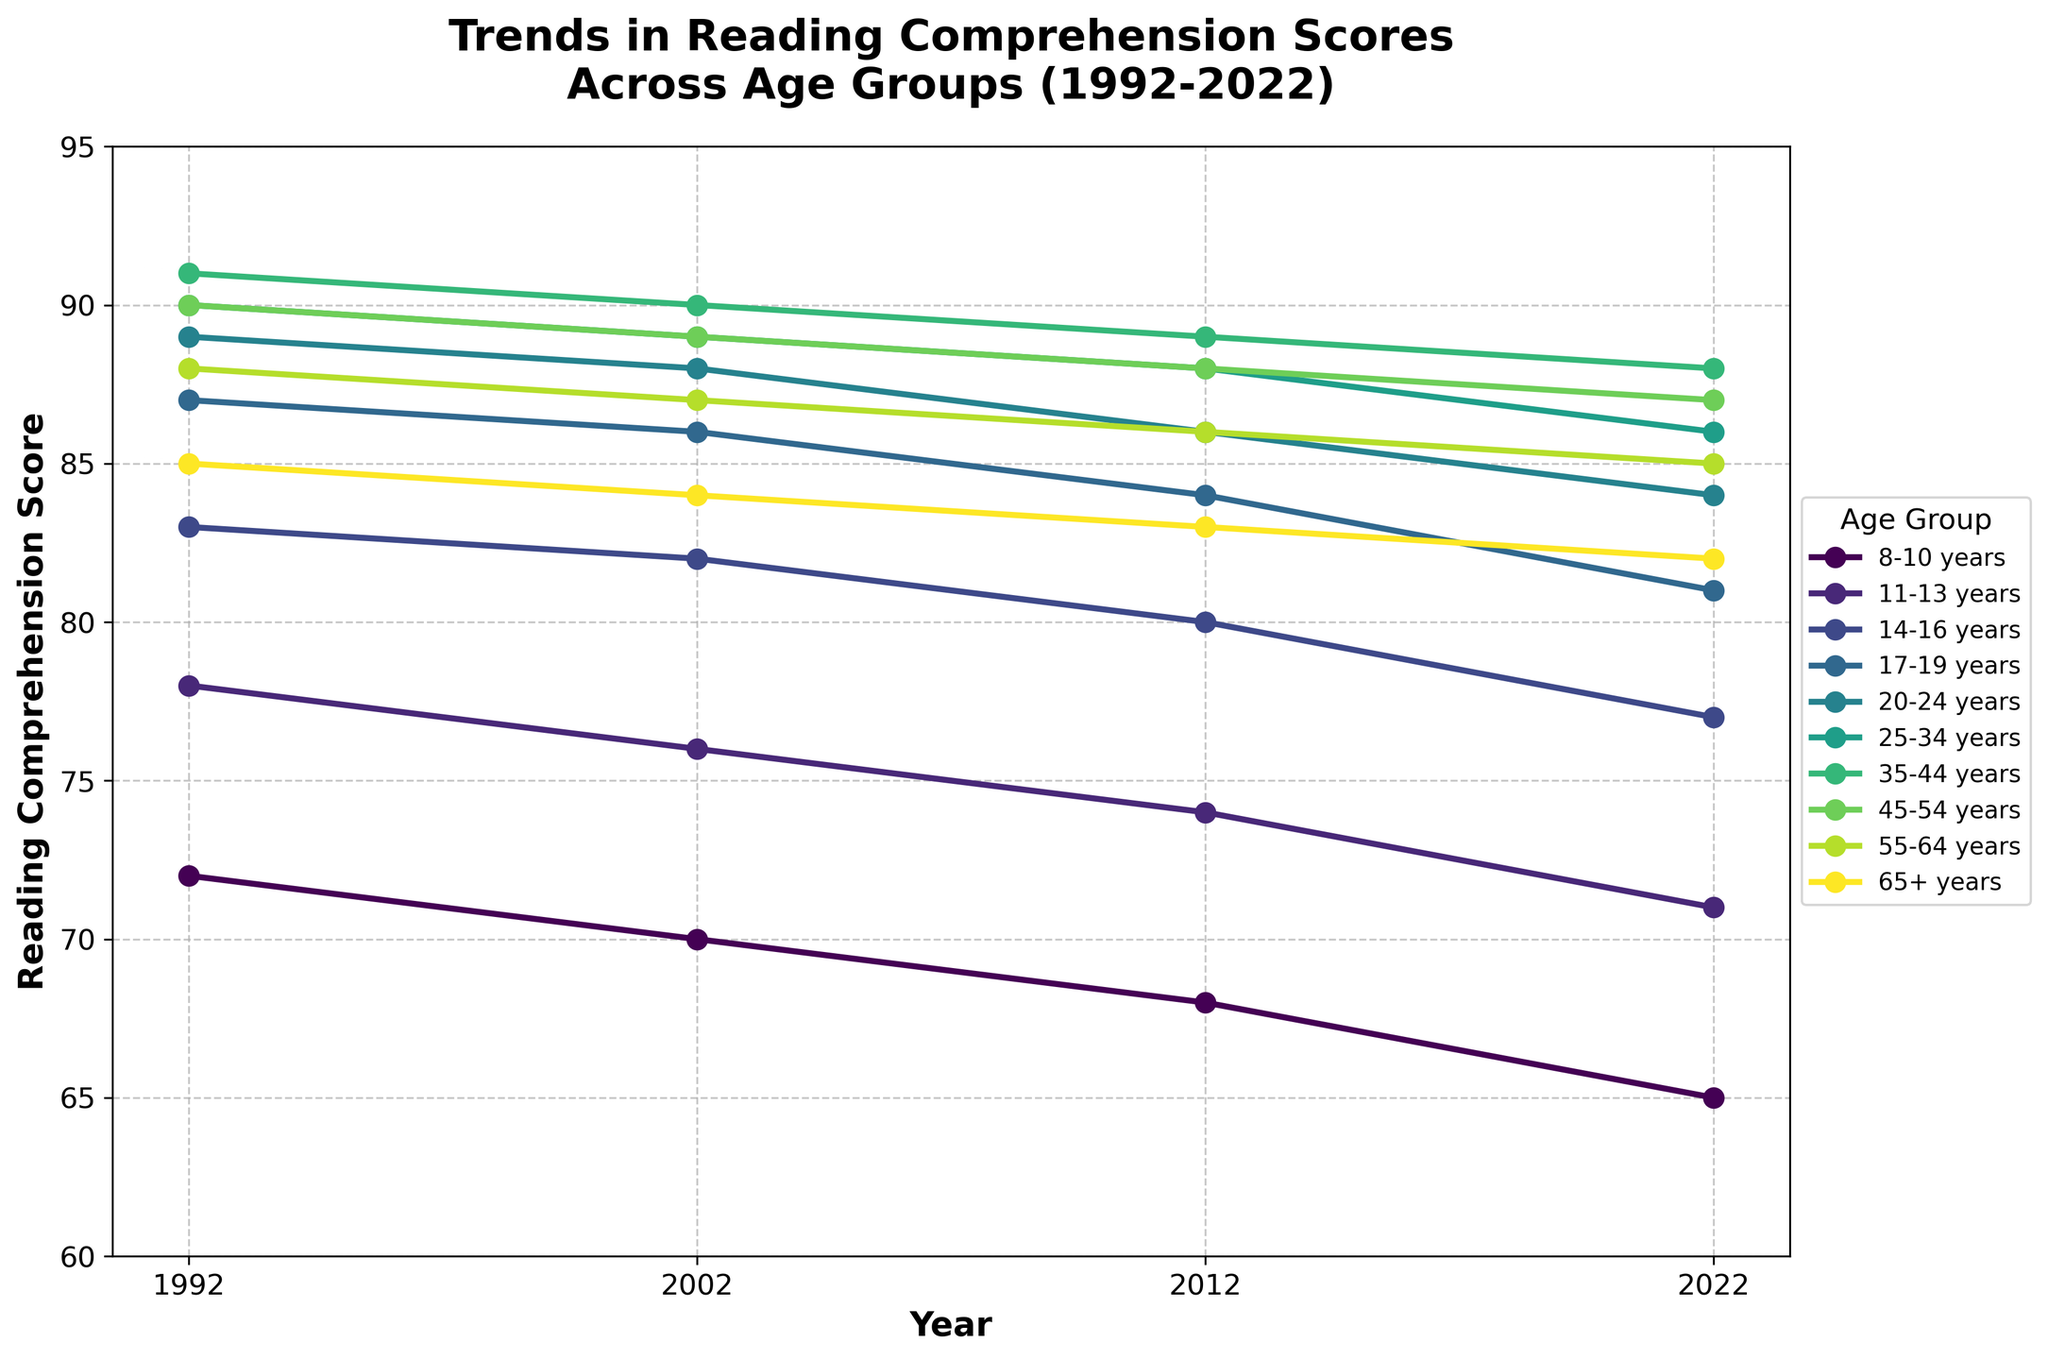Which age group exhibited the highest reading comprehension score in 2022? Look at the 2022 values on the plot and identify the highest value. The age group with the highest score is 35-44 years, with a score of 88.
Answer: 35-44 years How did the score for the 17-19 years age group change from 1992 to 2022? Examine the line for the 17-19 years group. In 1992, the score was 87. By 2022, it dropped to 81. The change is a decrease of 6 points.
Answer: Decreased by 6 points Between which years did the 8-10 years age group see the steepest decline in reading comprehension scores? Compare the slopes of the 8-10 years age group's line segments between each set of consecutive years. The steepest decline is from 2012 to 2022, where the score dropped from 68 to 65, a decline of 3 points.
Answer: 2012 to 2022 What is the average score for the 25-34 years age group over the 30 years? Sum the scores for the 25-34 years age group: 90 + 89 + 88 + 86. Divide this sum by the number of data points, 4. Hence, (90 + 89 + 88 + 86) / 4 = 88.25.
Answer: 88.25 How many age groups had scores above 85 in 1992? Observe the 1992 values and count the age groups with scores above 85. The groups are 14-16, 17-19, 20-24, 25-34, and 35-44 years, making a total of 5 age groups.
Answer: 5 Which age group had the smallest total drop in scores over the 30 years? Calculate the total drop for each age group by subtracting the 2022 score from the 1992 score. The group with the smallest drop is 35-44 years, with a drop from 91 to 88, resulting in a decrease of 3 points.
Answer: 35-44 years Which age group's scores are represented by the color at the top of the color palette? Look at the line color corresponding to the age group at the topmost position in the color gradient on the plot. This age group is 8-10 years.
Answer: 8-10 years Compare the scores of the 55-64 years and 65+ years age groups in 2022. Which one is higher? Compare the 2022 scores for both groups. The 55-64 years group has a score of 85, while the 65+ years group has a score of 82. The 55-64 years group's score is higher.
Answer: 55-64 years What is the average change in reading comprehension scores for the 14-16 years age group from each decade to the next? Calculate the differences for the 14-16 years age group's scores for each interval: 83 to 82 (1992-2002), 82 to 80 (2002-2012), and 80 to 77 (2012-2022). The total change is (83-82) + (82-80) + (80-77) = 3. Divide this by the number of intervals, 3: 3 / 3 = 1.
Answer: 1 Which age group experienced the most significant decline between 1992 and 2022? Compute the total drop for each age group from 1992 to 2022. The 8-10 years age group saw the most significant decline, dropping from 72 to 65, which is a decrease of 7 points.
Answer: 8-10 years 